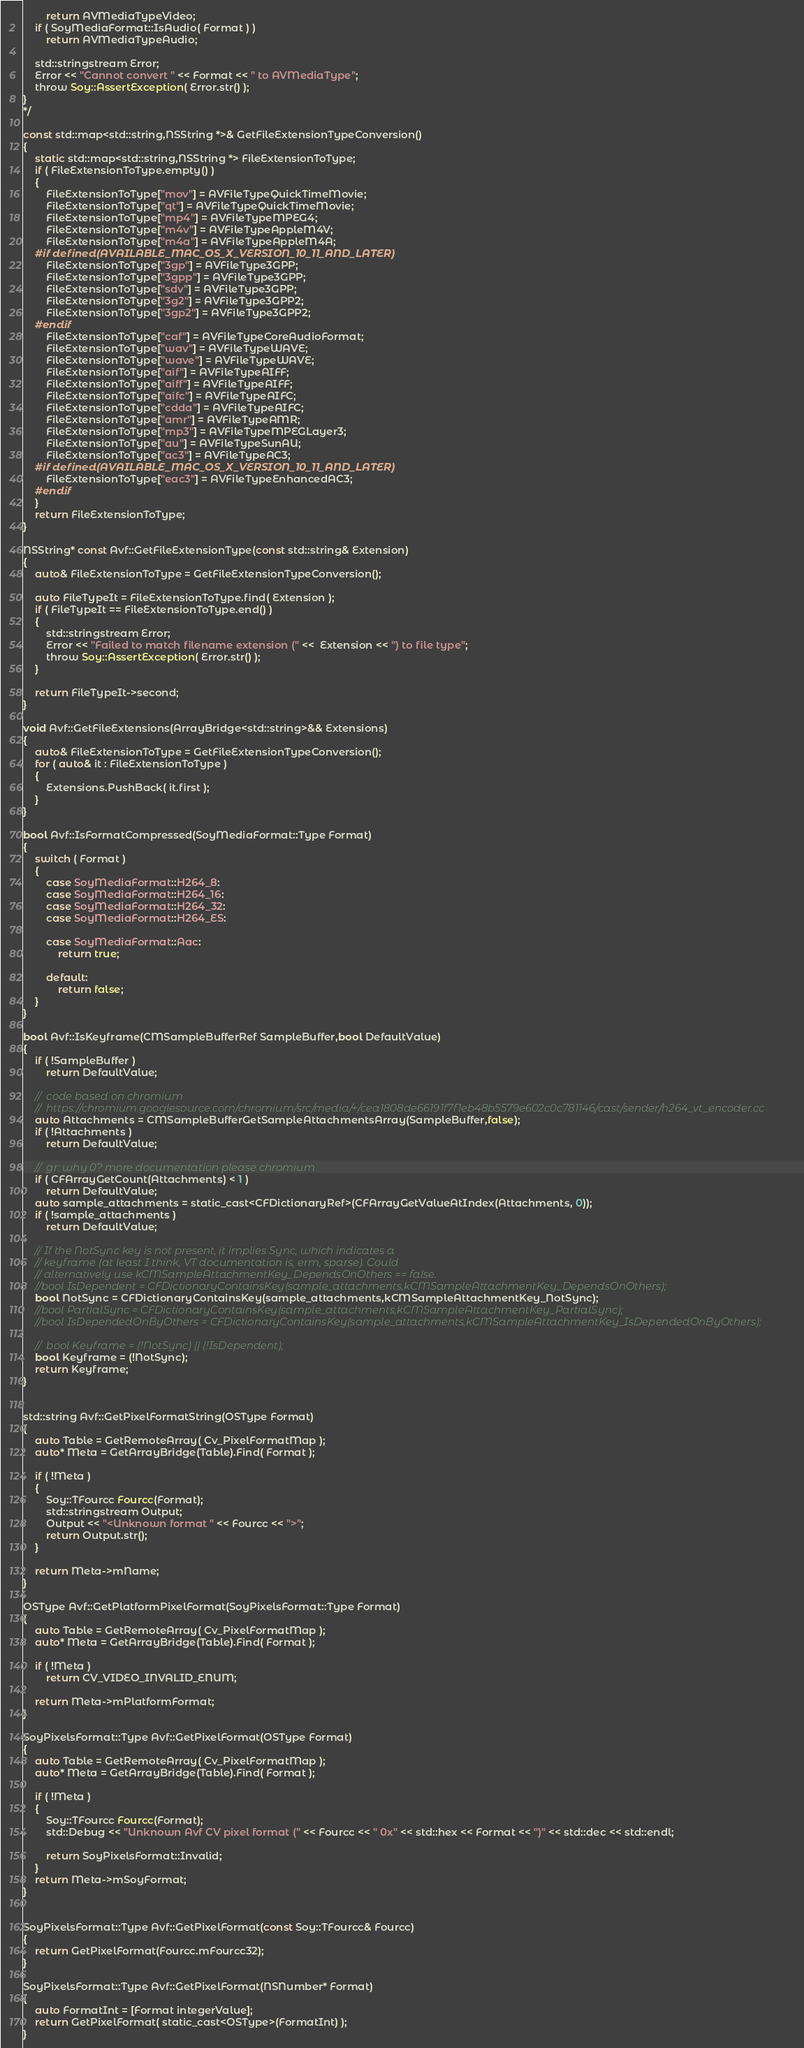Convert code to text. <code><loc_0><loc_0><loc_500><loc_500><_ObjectiveC_>		return AVMediaTypeVideo;
	if ( SoyMediaFormat::IsAudio( Format ) )
		return AVMediaTypeAudio;
	
	std::stringstream Error;
	Error << "Cannot convert " << Format << " to AVMediaType";
	throw Soy::AssertException( Error.str() );
}
*/

const std::map<std::string,NSString *>& GetFileExtensionTypeConversion()
{
	static std::map<std::string,NSString *> FileExtensionToType;
	if ( FileExtensionToType.empty() )
	{
		FileExtensionToType["mov"] = AVFileTypeQuickTimeMovie;
		FileExtensionToType["qt"] = AVFileTypeQuickTimeMovie;
		FileExtensionToType["mp4"] = AVFileTypeMPEG4;
		FileExtensionToType["m4v"] = AVFileTypeAppleM4V;
		FileExtensionToType["m4a"] = AVFileTypeAppleM4A;
	#if defined(AVAILABLE_MAC_OS_X_VERSION_10_11_AND_LATER)
		FileExtensionToType["3gp"] = AVFileType3GPP;
		FileExtensionToType["3gpp"] = AVFileType3GPP;
		FileExtensionToType["sdv"] = AVFileType3GPP;
		FileExtensionToType["3g2"] = AVFileType3GPP2;
		FileExtensionToType["3gp2"] = AVFileType3GPP2;
	#endif
		FileExtensionToType["caf"] = AVFileTypeCoreAudioFormat;
		FileExtensionToType["wav"] = AVFileTypeWAVE;
		FileExtensionToType["wave"] = AVFileTypeWAVE;
		FileExtensionToType["aif"] = AVFileTypeAIFF;
		FileExtensionToType["aiff"] = AVFileTypeAIFF;
		FileExtensionToType["aifc"] = AVFileTypeAIFC;
		FileExtensionToType["cdda"] = AVFileTypeAIFC;
		FileExtensionToType["amr"] = AVFileTypeAMR;
		FileExtensionToType["mp3"] = AVFileTypeMPEGLayer3;
		FileExtensionToType["au"] = AVFileTypeSunAU;
		FileExtensionToType["ac3"] = AVFileTypeAC3;
	#if defined(AVAILABLE_MAC_OS_X_VERSION_10_11_AND_LATER)
		FileExtensionToType["eac3"] = AVFileTypeEnhancedAC3;
	#endif
	}
	return FileExtensionToType;
}

NSString* const Avf::GetFileExtensionType(const std::string& Extension)
{
	auto& FileExtensionToType = GetFileExtensionTypeConversion();
	
	auto FileTypeIt = FileExtensionToType.find( Extension );
	if ( FileTypeIt == FileExtensionToType.end() )
	{
		std::stringstream Error;
		Error << "Failed to match filename extension (" <<  Extension << ") to file type";
		throw Soy::AssertException( Error.str() );
	}
	
	return FileTypeIt->second;
}

void Avf::GetFileExtensions(ArrayBridge<std::string>&& Extensions)
{
	auto& FileExtensionToType = GetFileExtensionTypeConversion();
	for ( auto& it : FileExtensionToType )
	{
		Extensions.PushBack( it.first );
	}
}

bool Avf::IsFormatCompressed(SoyMediaFormat::Type Format)
{
	switch ( Format )
	{
		case SoyMediaFormat::H264_8:
		case SoyMediaFormat::H264_16:
		case SoyMediaFormat::H264_32:
		case SoyMediaFormat::H264_ES:

		case SoyMediaFormat::Aac:
			return true;
			
		default:
			return false;
	}
}

bool Avf::IsKeyframe(CMSampleBufferRef SampleBuffer,bool DefaultValue)
{
	if ( !SampleBuffer )
		return DefaultValue;

	//	code based on chromium
	//	https://chromium.googlesource.com/chromium/src/media/+/cea1808de66191f7f1eb48b5579e602c0c781146/cast/sender/h264_vt_encoder.cc
	auto Attachments = CMSampleBufferGetSampleAttachmentsArray(SampleBuffer,false);
	if ( !Attachments )
		return DefaultValue;

	//	gr: why 0? more documentation please chromium
	if ( CFArrayGetCount(Attachments) < 1 )
		return DefaultValue;
	auto sample_attachments = static_cast<CFDictionaryRef>(CFArrayGetValueAtIndex(Attachments, 0));
	if ( !sample_attachments )
		return DefaultValue;
	
	// If the NotSync key is not present, it implies Sync, which indicates a
	// keyframe (at least I think, VT documentation is, erm, sparse). Could
	// alternatively use kCMSampleAttachmentKey_DependsOnOthers == false.
	//bool IsDependent = CFDictionaryContainsKey(sample_attachments,kCMSampleAttachmentKey_DependsOnOthers);
	bool NotSync = CFDictionaryContainsKey(sample_attachments,kCMSampleAttachmentKey_NotSync);
	//bool PartialSync = CFDictionaryContainsKey(sample_attachments,kCMSampleAttachmentKey_PartialSync);
	//bool IsDependedOnByOthers = CFDictionaryContainsKey(sample_attachments,kCMSampleAttachmentKey_IsDependedOnByOthers);
	
	//	bool Keyframe = (!NotSync) || (!IsDependent);
	bool Keyframe = (!NotSync);
	return Keyframe;
}


std::string Avf::GetPixelFormatString(OSType Format)
{
	auto Table = GetRemoteArray( Cv_PixelFormatMap );
	auto* Meta = GetArrayBridge(Table).Find( Format );
	
	if ( !Meta )
	{
		Soy::TFourcc Fourcc(Format);
		std::stringstream Output;
		Output << "<Unknown format " << Fourcc << ">";
		return Output.str();
	}

	return Meta->mName;
}

OSType Avf::GetPlatformPixelFormat(SoyPixelsFormat::Type Format)
{
	auto Table = GetRemoteArray( Cv_PixelFormatMap );
	auto* Meta = GetArrayBridge(Table).Find( Format );

	if ( !Meta )
		return CV_VIDEO_INVALID_ENUM;
	
	return Meta->mPlatformFormat;
}

SoyPixelsFormat::Type Avf::GetPixelFormat(OSType Format)
{
	auto Table = GetRemoteArray( Cv_PixelFormatMap );
	auto* Meta = GetArrayBridge(Table).Find( Format );
	
	if ( !Meta )
	{
		Soy::TFourcc Fourcc(Format);
		std::Debug << "Unknown Avf CV pixel format (" << Fourcc << " 0x" << std::hex << Format << ")" << std::dec << std::endl;
		
		return SoyPixelsFormat::Invalid;
	}
	return Meta->mSoyFormat;
}


SoyPixelsFormat::Type Avf::GetPixelFormat(const Soy::TFourcc& Fourcc)
{
	return GetPixelFormat(Fourcc.mFourcc32);
}

SoyPixelsFormat::Type Avf::GetPixelFormat(NSNumber* Format)
{
	auto FormatInt = [Format integerValue];
	return GetPixelFormat( static_cast<OSType>(FormatInt) );
}

</code> 